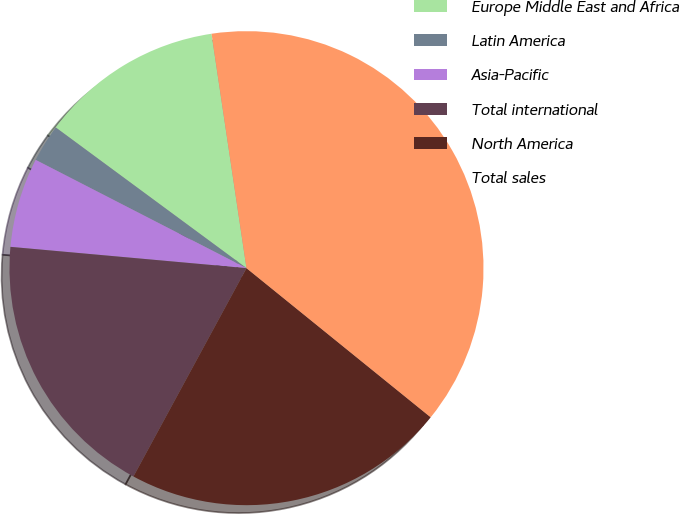Convert chart to OTSL. <chart><loc_0><loc_0><loc_500><loc_500><pie_chart><fcel>Europe Middle East and Africa<fcel>Latin America<fcel>Asia-Pacific<fcel>Total international<fcel>North America<fcel>Total sales<nl><fcel>12.53%<fcel>2.56%<fcel>6.12%<fcel>18.52%<fcel>22.08%<fcel>38.19%<nl></chart> 